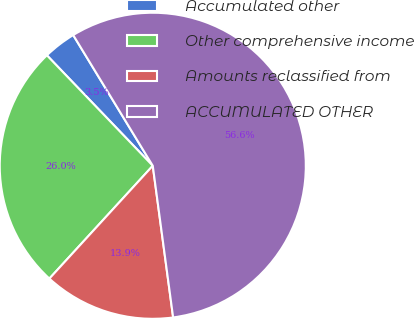Convert chart. <chart><loc_0><loc_0><loc_500><loc_500><pie_chart><fcel>Accumulated other<fcel>Other comprehensive income<fcel>Amounts reclassified from<fcel>ACCUMULATED OTHER<nl><fcel>3.46%<fcel>26.03%<fcel>13.93%<fcel>56.58%<nl></chart> 